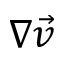Convert formula to latex. <formula><loc_0><loc_0><loc_500><loc_500>\nabla \vec { v }</formula> 